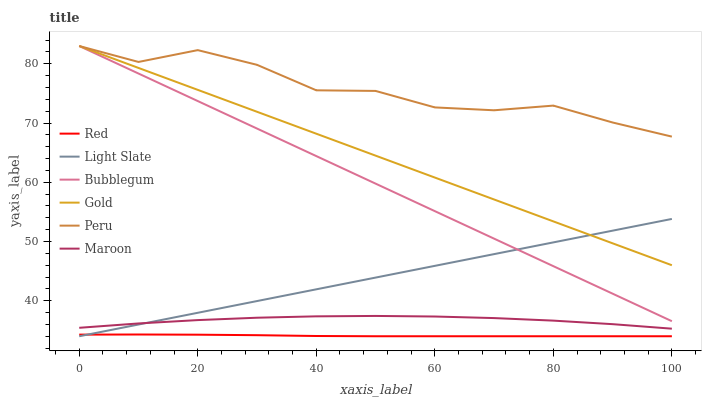Does Red have the minimum area under the curve?
Answer yes or no. Yes. Does Peru have the maximum area under the curve?
Answer yes or no. Yes. Does Light Slate have the minimum area under the curve?
Answer yes or no. No. Does Light Slate have the maximum area under the curve?
Answer yes or no. No. Is Light Slate the smoothest?
Answer yes or no. Yes. Is Peru the roughest?
Answer yes or no. Yes. Is Maroon the smoothest?
Answer yes or no. No. Is Maroon the roughest?
Answer yes or no. No. Does Maroon have the lowest value?
Answer yes or no. No. Does Peru have the highest value?
Answer yes or no. Yes. Does Light Slate have the highest value?
Answer yes or no. No. Is Maroon less than Bubblegum?
Answer yes or no. Yes. Is Peru greater than Maroon?
Answer yes or no. Yes. Does Gold intersect Light Slate?
Answer yes or no. Yes. Is Gold less than Light Slate?
Answer yes or no. No. Is Gold greater than Light Slate?
Answer yes or no. No. Does Maroon intersect Bubblegum?
Answer yes or no. No. 